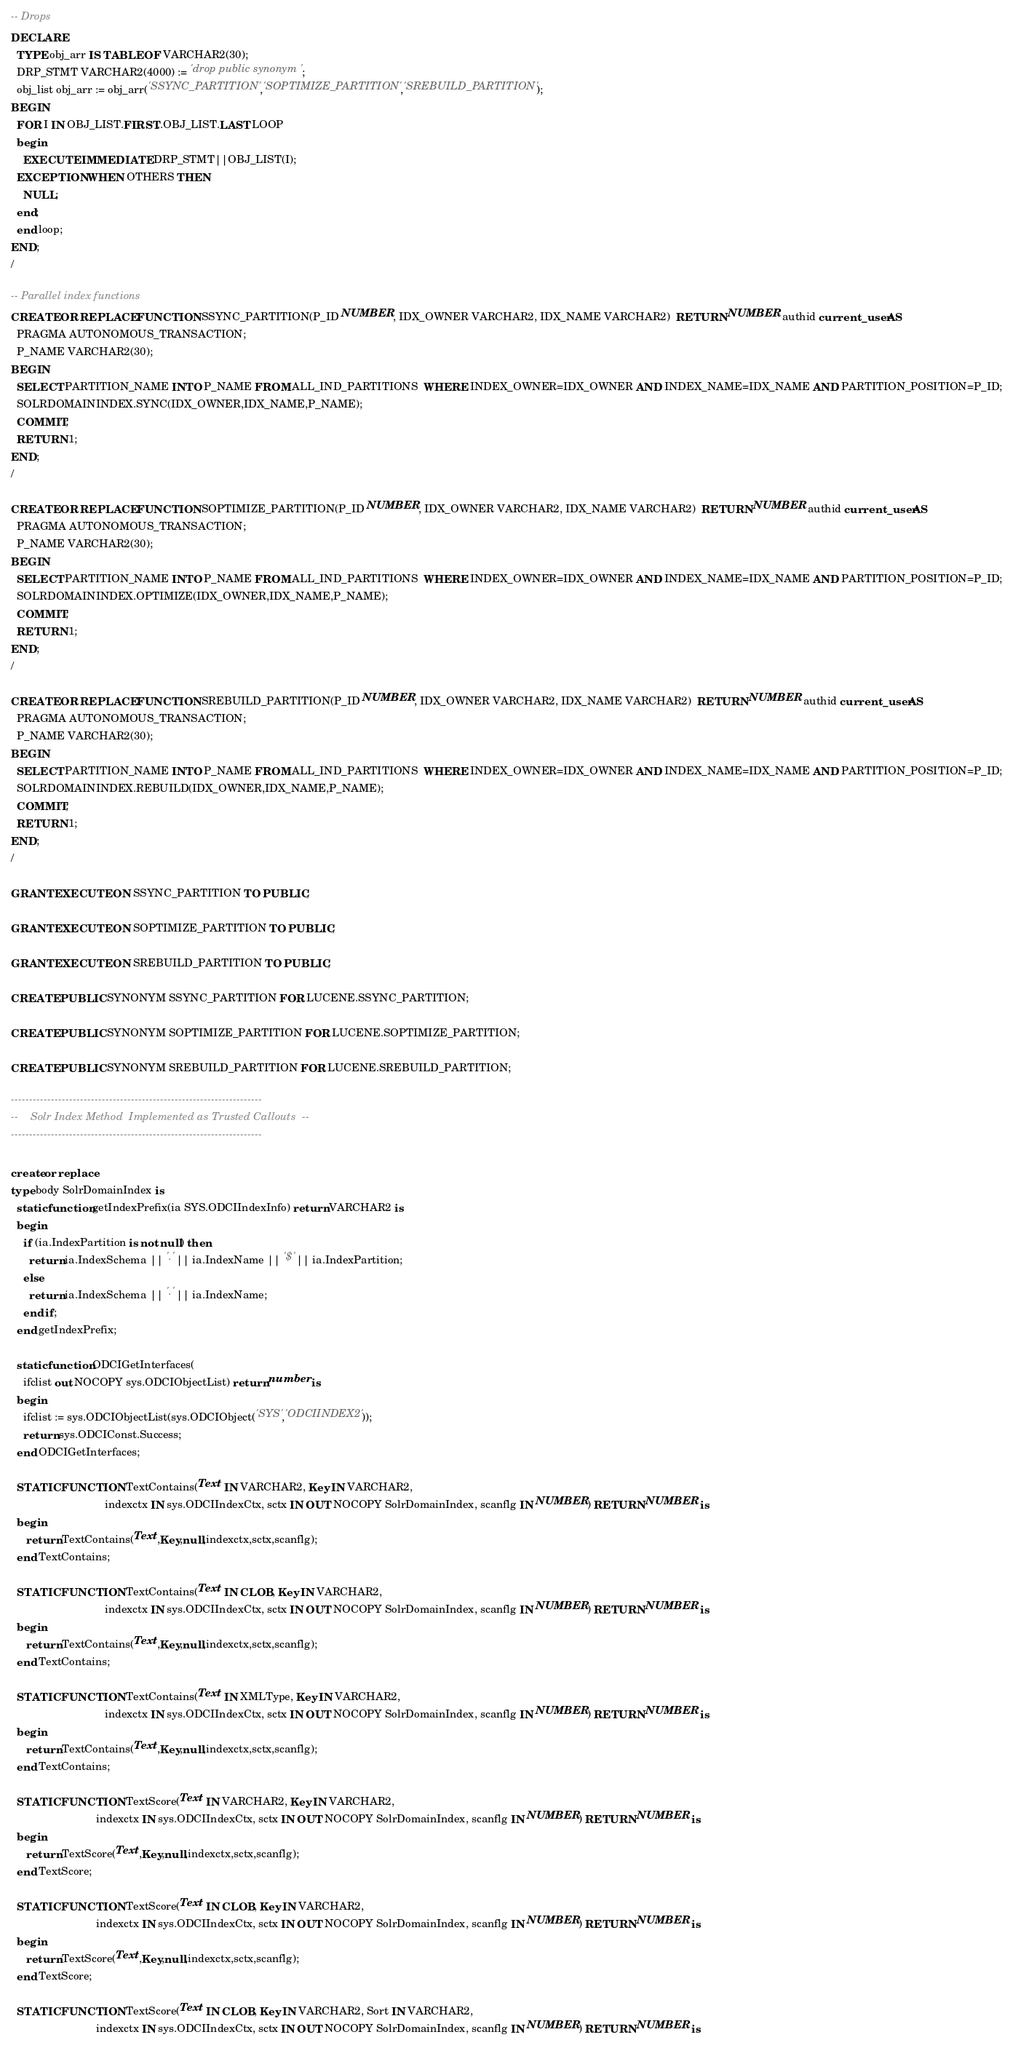<code> <loc_0><loc_0><loc_500><loc_500><_SQL_>-- Drops
DECLARE
  TYPE obj_arr IS TABLE OF VARCHAR2(30);
  DRP_STMT VARCHAR2(4000) := 'drop public synonym ';
  obj_list obj_arr := obj_arr('SSYNC_PARTITION','SOPTIMIZE_PARTITION','SREBUILD_PARTITION');
BEGIN
  FOR I IN OBJ_LIST.FIRST..OBJ_LIST.LAST LOOP
  begin
    EXECUTE IMMEDIATE DRP_STMT||OBJ_LIST(I);
  EXCEPTION WHEN OTHERS THEN
    NULL;
  end;
  end loop;
END;
/

-- Parallel index functions
CREATE OR REPLACE FUNCTION SSYNC_PARTITION(P_ID NUMBER, IDX_OWNER VARCHAR2, IDX_NAME VARCHAR2)  RETURN NUMBER authid current_user AS 
  PRAGMA AUTONOMOUS_TRANSACTION;
  P_NAME VARCHAR2(30);
BEGIN
  SELECT PARTITION_NAME INTO P_NAME FROM ALL_IND_PARTITIONS  WHERE INDEX_OWNER=IDX_OWNER AND INDEX_NAME=IDX_NAME AND PARTITION_POSITION=P_ID;
  SOLRDOMAININDEX.SYNC(IDX_OWNER,IDX_NAME,P_NAME);
  COMMIT;
  RETURN 1;
END;
/

CREATE OR REPLACE FUNCTION SOPTIMIZE_PARTITION(P_ID NUMBER, IDX_OWNER VARCHAR2, IDX_NAME VARCHAR2)  RETURN NUMBER authid current_user AS
  PRAGMA AUTONOMOUS_TRANSACTION;
  P_NAME VARCHAR2(30);
BEGIN
  SELECT PARTITION_NAME INTO P_NAME FROM ALL_IND_PARTITIONS  WHERE INDEX_OWNER=IDX_OWNER AND INDEX_NAME=IDX_NAME AND PARTITION_POSITION=P_ID;
  SOLRDOMAININDEX.OPTIMIZE(IDX_OWNER,IDX_NAME,P_NAME);
  COMMIT;
  RETURN 1;
END;
/

CREATE OR REPLACE FUNCTION SREBUILD_PARTITION(P_ID NUMBER, IDX_OWNER VARCHAR2, IDX_NAME VARCHAR2)  RETURN NUMBER authid current_user AS
  PRAGMA AUTONOMOUS_TRANSACTION;
  P_NAME VARCHAR2(30);
BEGIN
  SELECT PARTITION_NAME INTO P_NAME FROM ALL_IND_PARTITIONS  WHERE INDEX_OWNER=IDX_OWNER AND INDEX_NAME=IDX_NAME AND PARTITION_POSITION=P_ID;
  SOLRDOMAININDEX.REBUILD(IDX_OWNER,IDX_NAME,P_NAME);
  COMMIT;
  RETURN 1;
END;
/

GRANT EXECUTE ON SSYNC_PARTITION TO PUBLIC;

GRANT EXECUTE ON SOPTIMIZE_PARTITION TO PUBLIC;

GRANT EXECUTE ON SREBUILD_PARTITION TO PUBLIC;

CREATE PUBLIC SYNONYM SSYNC_PARTITION FOR LUCENE.SSYNC_PARTITION;

CREATE PUBLIC SYNONYM SOPTIMIZE_PARTITION FOR LUCENE.SOPTIMIZE_PARTITION;

CREATE PUBLIC SYNONYM SREBUILD_PARTITION FOR LUCENE.SREBUILD_PARTITION;

---------------------------------------------------------------------
--    Solr Index Method  Implemented as Trusted Callouts  --
---------------------------------------------------------------------

create or replace
type body SolrDomainIndex is
  static function getIndexPrefix(ia SYS.ODCIIndexInfo) return VARCHAR2 is
  begin
    if (ia.IndexPartition is not null) then
      return ia.IndexSchema || '.' || ia.IndexName || '$' || ia.IndexPartition;
    else
      return ia.IndexSchema || '.' || ia.IndexName;
    end if;
  end getIndexPrefix;

  static function ODCIGetInterfaces(
    ifclist out NOCOPY sys.ODCIObjectList) return number is
  begin
    ifclist := sys.ODCIObjectList(sys.ODCIObject('SYS','ODCIINDEX2'));
    return sys.ODCIConst.Success;
  end ODCIGetInterfaces;

  STATIC FUNCTION TextContains(Text IN VARCHAR2, Key IN VARCHAR2,
                               indexctx IN sys.ODCIIndexCtx, sctx IN OUT NOCOPY SolrDomainIndex, scanflg IN NUMBER) RETURN NUMBER is
  begin
     return TextContains(Text,Key,null,indexctx,sctx,scanflg);
  end TextContains;

  STATIC FUNCTION TextContains(Text IN CLOB, Key IN VARCHAR2,
                               indexctx IN sys.ODCIIndexCtx, sctx IN OUT NOCOPY SolrDomainIndex, scanflg IN NUMBER) RETURN NUMBER is
  begin
     return TextContains(Text,Key,null,indexctx,sctx,scanflg);
  end TextContains;

  STATIC FUNCTION TextContains(Text IN XMLType, Key IN VARCHAR2,
                               indexctx IN sys.ODCIIndexCtx, sctx IN OUT NOCOPY SolrDomainIndex, scanflg IN NUMBER) RETURN NUMBER is
  begin
     return TextContains(Text,Key,null,indexctx,sctx,scanflg);
  end TextContains;

  STATIC FUNCTION TextScore(Text IN VARCHAR2, Key IN VARCHAR2,
                            indexctx IN sys.ODCIIndexCtx, sctx IN OUT NOCOPY SolrDomainIndex, scanflg IN NUMBER) RETURN NUMBER is
  begin
     return TextScore(Text,Key,null,indexctx,sctx,scanflg);
  end TextScore;

  STATIC FUNCTION TextScore(Text IN CLOB, Key IN VARCHAR2,
                            indexctx IN sys.ODCIIndexCtx, sctx IN OUT NOCOPY SolrDomainIndex, scanflg IN NUMBER) RETURN NUMBER is
  begin
     return TextScore(Text,Key,null,indexctx,sctx,scanflg);
  end TextScore;

  STATIC FUNCTION TextScore(Text IN CLOB, Key IN VARCHAR2, Sort IN VARCHAR2,
                            indexctx IN sys.ODCIIndexCtx, sctx IN OUT NOCOPY SolrDomainIndex, scanflg IN NUMBER) RETURN NUMBER is</code> 